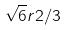Convert formula to latex. <formula><loc_0><loc_0><loc_500><loc_500>\sqrt { 6 } r 2 / 3</formula> 